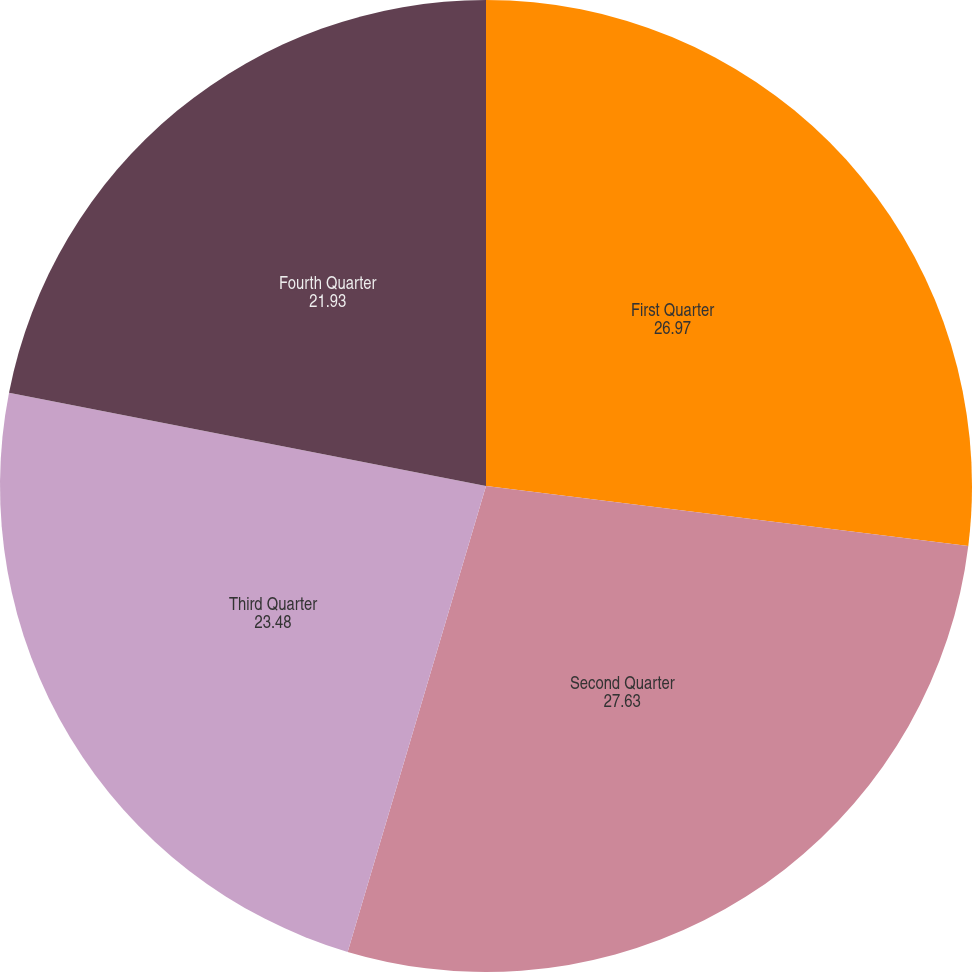<chart> <loc_0><loc_0><loc_500><loc_500><pie_chart><fcel>First Quarter<fcel>Second Quarter<fcel>Third Quarter<fcel>Fourth Quarter<nl><fcel>26.97%<fcel>27.63%<fcel>23.48%<fcel>21.93%<nl></chart> 